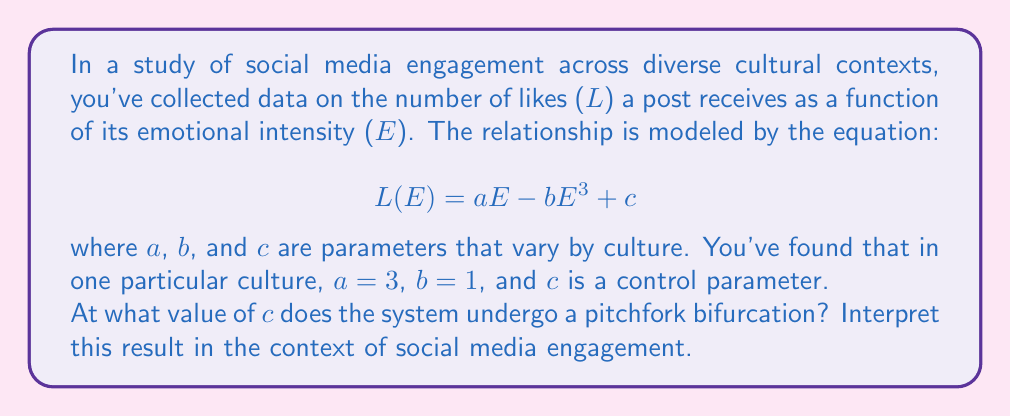Can you solve this math problem? To find the pitchfork bifurcation point, we need to follow these steps:

1) First, we need to find the fixed points of the system. These occur where $L(E) = E$:

   $$E = 3E - E^3 + c$$

2) Rearranging this equation:

   $$E^3 - 2E + c = 0$$

3) At the bifurcation point, this equation will have three identical roots. This occurs when both the function and its derivative are zero at the same point. Let's find the derivative:

   $$\frac{d}{dE}(E^3 - 2E + c) = 3E^2 - 2$$

4) Setting this equal to zero:

   $$3E^2 - 2 = 0$$
   $$3E^2 = 2$$
   $$E^2 = \frac{2}{3}$$
   $$E = \pm \sqrt{\frac{2}{3}}$$

5) Since we're looking for the point where all three roots are identical, we'll use the positive value:

   $$E = \sqrt{\frac{2}{3}}$$

6) Now, we can substitute this back into the original equation to find $c$:

   $$(\sqrt{\frac{2}{3}})^3 - 2(\sqrt{\frac{2}{3}}) + c = 0$$

7) Simplifying:

   $$\frac{2\sqrt{2}}{3\sqrt{3}} - 2\sqrt{\frac{2}{3}} + c = 0$$
   $$c = 2\sqrt{\frac{2}{3}} - \frac{2\sqrt{2}}{3\sqrt{3}}$$

8) This can be further simplified to:

   $$c = \frac{4}{3\sqrt{3}}$$

Interpretation: At this critical value of $c$, the system undergoes a pitchfork bifurcation. In the context of social media engagement, this represents a tipping point where the relationship between emotional intensity and likes changes dramatically. Below this point, there's a single stable equilibrium. Above it, the system bifurcates into two stable equilibria and one unstable equilibrium, suggesting that beyond this point, posts tend to either receive very few or very many likes, with moderate engagement becoming unstable.
Answer: $c = \frac{4}{3\sqrt{3}}$ 